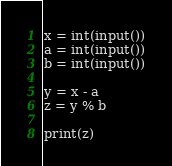<code> <loc_0><loc_0><loc_500><loc_500><_Python_>x = int(input())
a = int(input())
b = int(input())

y = x - a
z = y % b

print(z)
</code> 